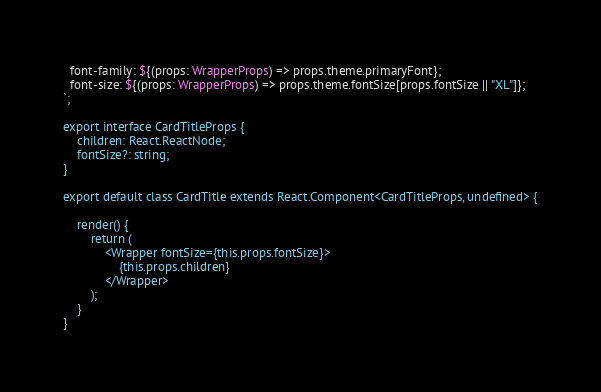<code> <loc_0><loc_0><loc_500><loc_500><_TypeScript_>  font-family: ${(props: WrapperProps) => props.theme.primaryFont};
  font-size: ${(props: WrapperProps) => props.theme.fontSize[props.fontSize || "XL"]};
`;

export interface CardTitleProps {
    children: React.ReactNode;
    fontSize?: string;
}

export default class CardTitle extends React.Component<CardTitleProps, undefined> {

    render() {
        return (
            <Wrapper fontSize={this.props.fontSize}>
                {this.props.children}
            </Wrapper>
        );
    }
}
</code> 